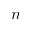<formula> <loc_0><loc_0><loc_500><loc_500>n</formula> 